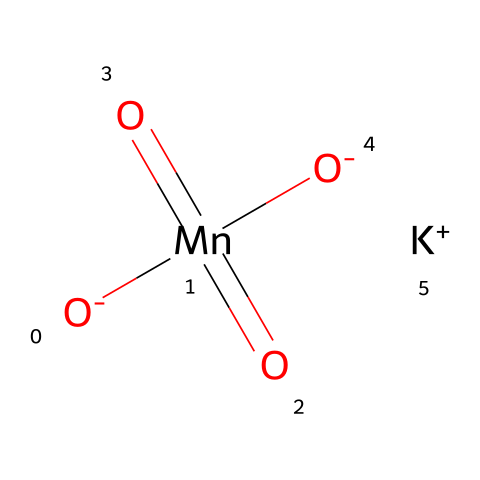What is the central atom in potassium permanganate? The structure shows manganese (Mn) as the central atom, bonded to several oxygen atoms. Manganese is located in the center of the chemical structure, which indicates it is the central atom.
Answer: manganese How many oxygen atoms are in potassium permanganate? By analyzing the SMILES representation, the chemical has four oxygen atoms attached to the manganese atom. Counting them yields a total of four oxygen atoms.
Answer: four What is the oxidation state of manganese in potassium permanganate? The oxidation state can be determined by considering that potassium (K) is +1 and each oxygen (O) bonded to manganese is typically -2. The oxidation state of Mn can be calculated as follows: x + 4(-2) + 1 = 0 → x - 8 + 1 = 0 → x = +7.
Answer: +7 What type of compound is potassium permanganate categorized as? This compound is categorized as an oxidizer due to its ability to accept electrons. The presence of a highly oxidized manganese species and the compound's general use in redox reactions signals its classification as an oxidizing agent.
Answer: oxidizer Which part of potassium permanganate is responsible for its strong oxidizing properties? The highly positive oxidation state of manganese (+7) and its electron-accepting capability make it a strong oxidizer. The ability of Mn(VII) to easily undergo reduction to lower oxidation states enables it to act as an effective oxidizing agent.
Answer: manganese What is one common application of potassium permanganate in scientific studies? Potassium permanganate is often used in redox titration and as a disinfectant in water treatment. Its strong oxidizing ability allows it to be applied effectively in various experiments involving oxidation-reduction reactions.
Answer: redox titration 